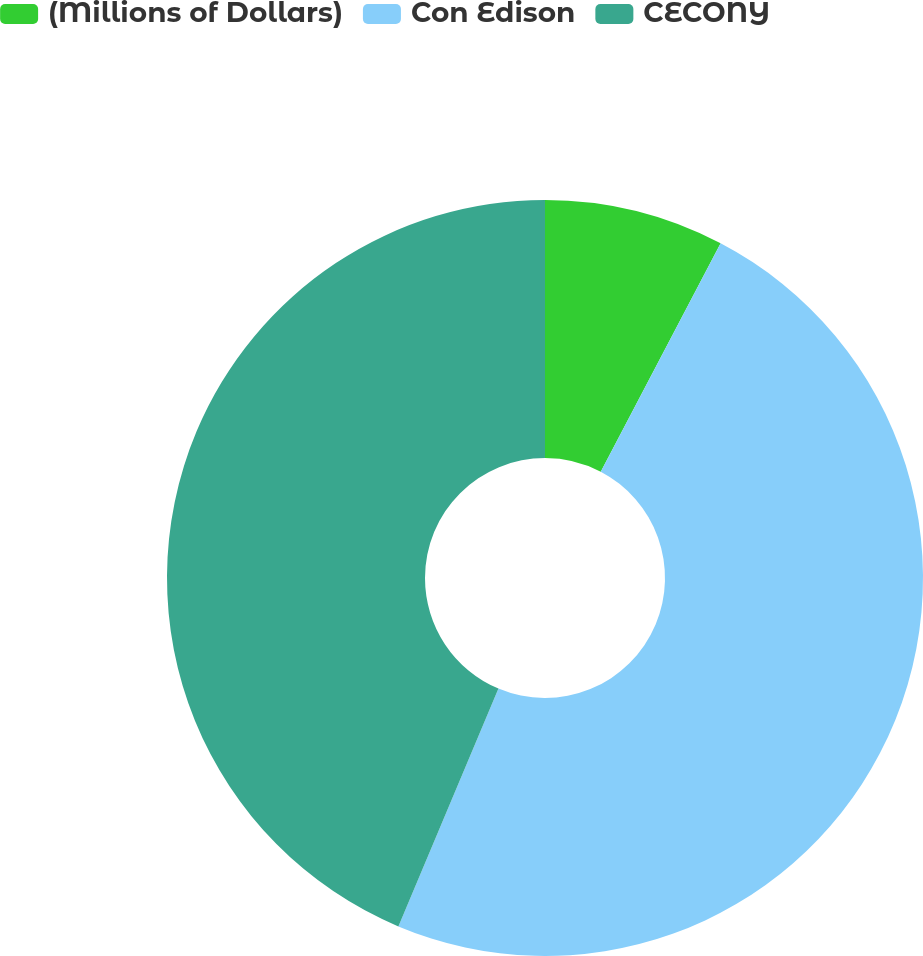<chart> <loc_0><loc_0><loc_500><loc_500><pie_chart><fcel>(Millions of Dollars)<fcel>Con Edison<fcel>CECONY<nl><fcel>7.69%<fcel>48.65%<fcel>43.66%<nl></chart> 